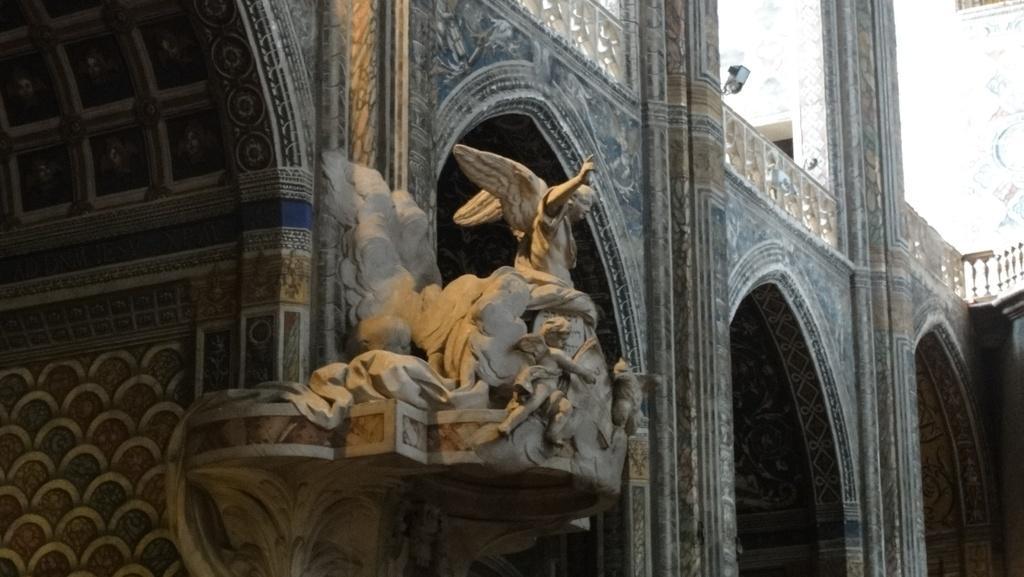Please provide a concise description of this image. The picture is of a building. Here there is a sculpture. The walls of the building are decorated. This is looking like a camera. 